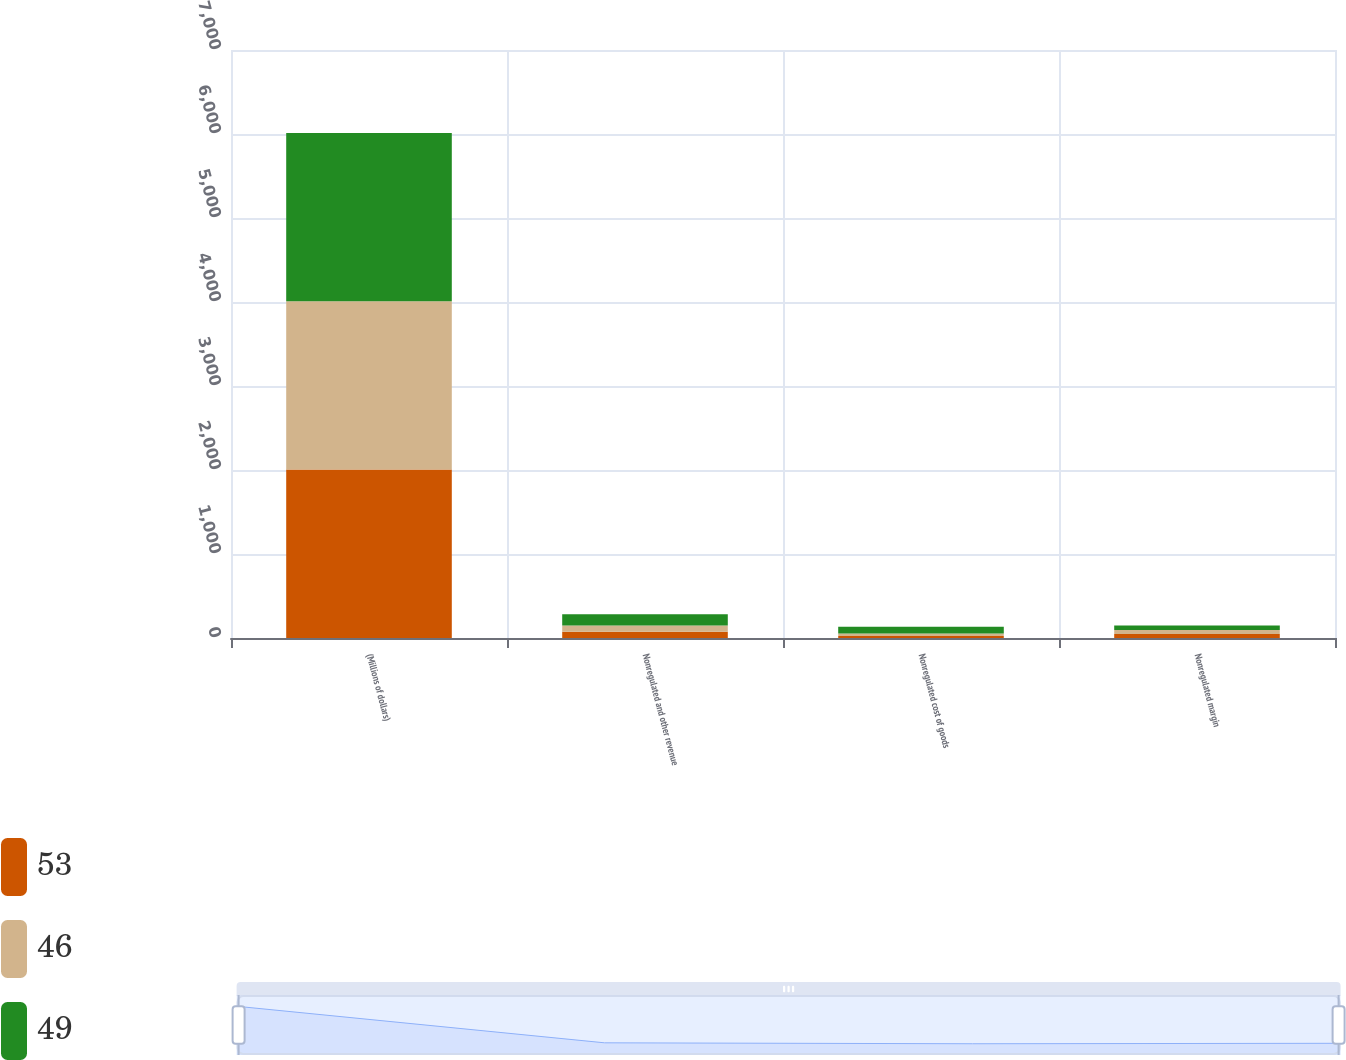Convert chart. <chart><loc_0><loc_0><loc_500><loc_500><stacked_bar_chart><ecel><fcel>(Millions of dollars)<fcel>Nonregulated and other revenue<fcel>Nonregulated cost of goods<fcel>Nonregulated margin<nl><fcel>53<fcel>2005<fcel>74<fcel>25<fcel>49<nl><fcel>46<fcel>2004<fcel>75<fcel>29<fcel>46<nl><fcel>49<fcel>2003<fcel>134<fcel>81<fcel>53<nl></chart> 